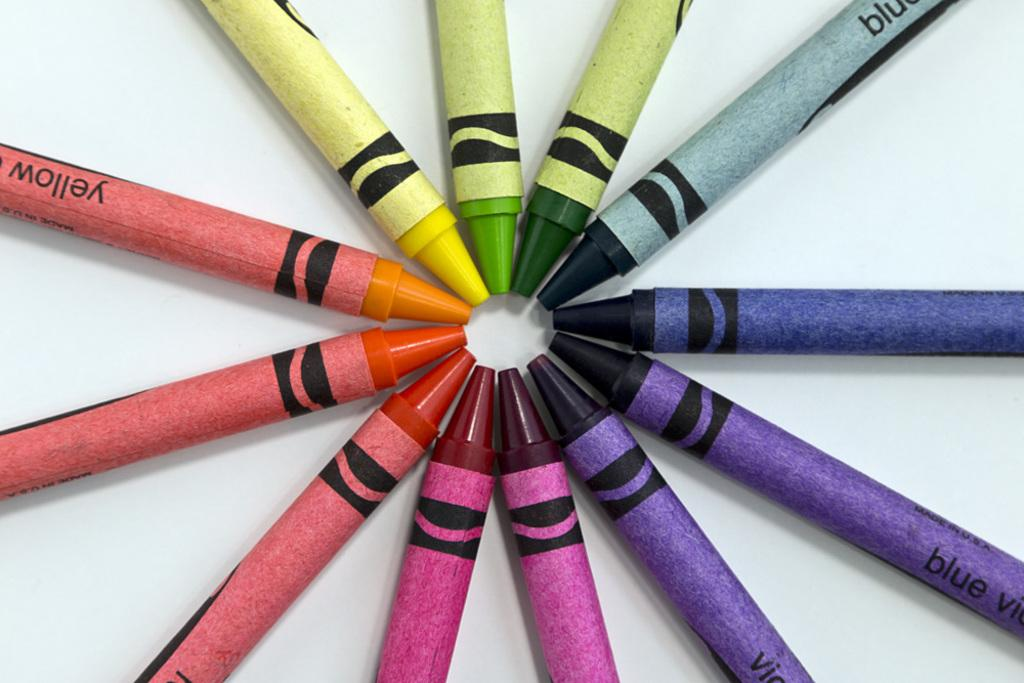What objects are on the floor in the image? There are crayon pencils on the floor. Where was the image taken? The image was taken in a room. Reasoning: Let' Let's think step by step in order to produce the conversation. We start by identifying the main subject in the image, which is the crayon pencils on the floor. Then, we expand the conversation to include the location of the image, which is a room. Each question is designed to elicit a specific detail about the image that is known from the provided facts. Absurd Question/Answer: What type of bee can be seen buzzing around the crayon pencils in the image? There is no bee present in the image; it only shows crayon pencils on the floor in a room. What type of plate is being used to serve the crayon pencils in the image? There is no plate present in the image; it only shows crayon pencils on the floor in a room. 